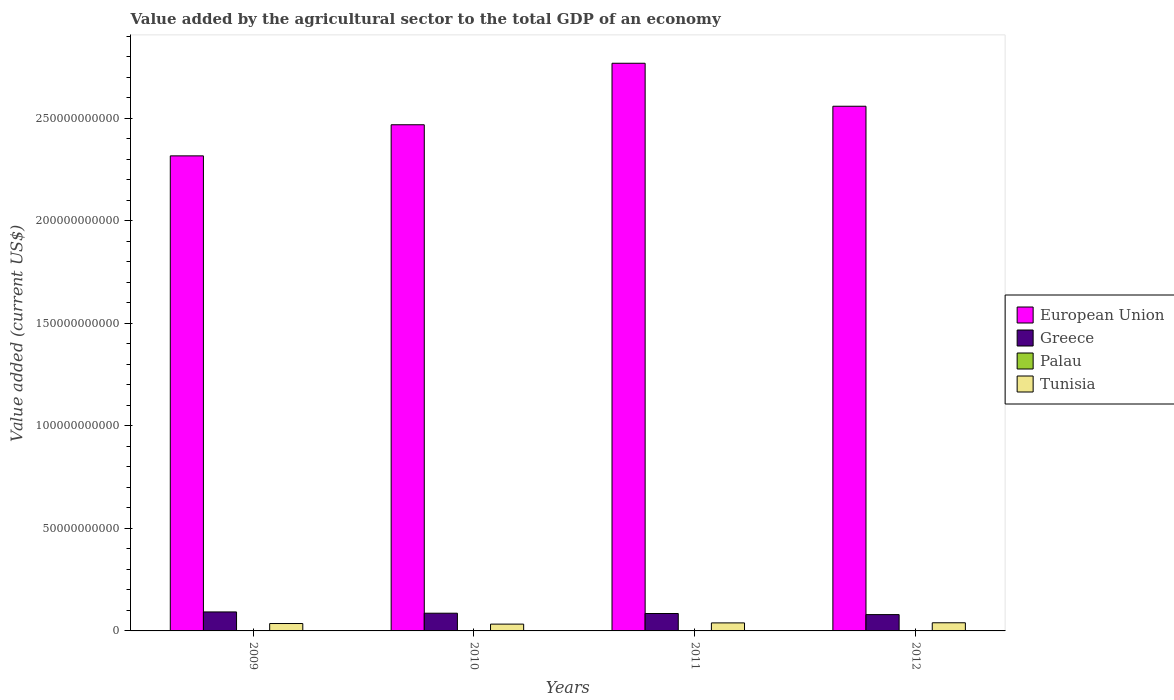Are the number of bars on each tick of the X-axis equal?
Ensure brevity in your answer.  Yes. How many bars are there on the 4th tick from the left?
Give a very brief answer. 4. How many bars are there on the 2nd tick from the right?
Your response must be concise. 4. What is the label of the 4th group of bars from the left?
Your answer should be very brief. 2012. In how many cases, is the number of bars for a given year not equal to the number of legend labels?
Offer a terse response. 0. What is the value added by the agricultural sector to the total GDP in Palau in 2009?
Give a very brief answer. 7.90e+06. Across all years, what is the maximum value added by the agricultural sector to the total GDP in European Union?
Give a very brief answer. 2.77e+11. Across all years, what is the minimum value added by the agricultural sector to the total GDP in Greece?
Provide a succinct answer. 7.95e+09. What is the total value added by the agricultural sector to the total GDP in Palau in the graph?
Provide a succinct answer. 3.33e+07. What is the difference between the value added by the agricultural sector to the total GDP in Greece in 2010 and that in 2011?
Offer a terse response. 1.43e+08. What is the difference between the value added by the agricultural sector to the total GDP in Tunisia in 2009 and the value added by the agricultural sector to the total GDP in Palau in 2012?
Provide a succinct answer. 3.60e+09. What is the average value added by the agricultural sector to the total GDP in European Union per year?
Your answer should be very brief. 2.53e+11. In the year 2010, what is the difference between the value added by the agricultural sector to the total GDP in European Union and value added by the agricultural sector to the total GDP in Greece?
Keep it short and to the point. 2.38e+11. In how many years, is the value added by the agricultural sector to the total GDP in Tunisia greater than 220000000000 US$?
Offer a very short reply. 0. What is the ratio of the value added by the agricultural sector to the total GDP in European Union in 2010 to that in 2012?
Offer a terse response. 0.96. Is the value added by the agricultural sector to the total GDP in Tunisia in 2010 less than that in 2011?
Keep it short and to the point. Yes. Is the difference between the value added by the agricultural sector to the total GDP in European Union in 2009 and 2011 greater than the difference between the value added by the agricultural sector to the total GDP in Greece in 2009 and 2011?
Your answer should be very brief. No. What is the difference between the highest and the second highest value added by the agricultural sector to the total GDP in Greece?
Your answer should be compact. 6.22e+08. What is the difference between the highest and the lowest value added by the agricultural sector to the total GDP in Palau?
Provide a short and direct response. 1.59e+06. Is the sum of the value added by the agricultural sector to the total GDP in European Union in 2009 and 2012 greater than the maximum value added by the agricultural sector to the total GDP in Tunisia across all years?
Provide a succinct answer. Yes. Is it the case that in every year, the sum of the value added by the agricultural sector to the total GDP in Tunisia and value added by the agricultural sector to the total GDP in Greece is greater than the sum of value added by the agricultural sector to the total GDP in Palau and value added by the agricultural sector to the total GDP in European Union?
Your answer should be very brief. No. What does the 4th bar from the left in 2009 represents?
Your answer should be very brief. Tunisia. Is it the case that in every year, the sum of the value added by the agricultural sector to the total GDP in European Union and value added by the agricultural sector to the total GDP in Palau is greater than the value added by the agricultural sector to the total GDP in Greece?
Offer a terse response. Yes. How many years are there in the graph?
Offer a terse response. 4. Does the graph contain any zero values?
Offer a terse response. No. Where does the legend appear in the graph?
Give a very brief answer. Center right. How many legend labels are there?
Your answer should be very brief. 4. How are the legend labels stacked?
Your answer should be compact. Vertical. What is the title of the graph?
Ensure brevity in your answer.  Value added by the agricultural sector to the total GDP of an economy. Does "Angola" appear as one of the legend labels in the graph?
Your answer should be very brief. No. What is the label or title of the Y-axis?
Your answer should be very brief. Value added (current US$). What is the Value added (current US$) of European Union in 2009?
Keep it short and to the point. 2.32e+11. What is the Value added (current US$) of Greece in 2009?
Ensure brevity in your answer.  9.26e+09. What is the Value added (current US$) in Palau in 2009?
Your answer should be very brief. 7.90e+06. What is the Value added (current US$) of Tunisia in 2009?
Keep it short and to the point. 3.61e+09. What is the Value added (current US$) in European Union in 2010?
Keep it short and to the point. 2.47e+11. What is the Value added (current US$) in Greece in 2010?
Your answer should be compact. 8.63e+09. What is the Value added (current US$) of Palau in 2010?
Provide a succinct answer. 7.58e+06. What is the Value added (current US$) of Tunisia in 2010?
Provide a short and direct response. 3.32e+09. What is the Value added (current US$) in European Union in 2011?
Offer a terse response. 2.77e+11. What is the Value added (current US$) of Greece in 2011?
Provide a succinct answer. 8.49e+09. What is the Value added (current US$) of Palau in 2011?
Keep it short and to the point. 8.69e+06. What is the Value added (current US$) in Tunisia in 2011?
Offer a terse response. 3.91e+09. What is the Value added (current US$) in European Union in 2012?
Keep it short and to the point. 2.56e+11. What is the Value added (current US$) in Greece in 2012?
Provide a short and direct response. 7.95e+09. What is the Value added (current US$) in Palau in 2012?
Ensure brevity in your answer.  9.17e+06. What is the Value added (current US$) of Tunisia in 2012?
Give a very brief answer. 3.98e+09. Across all years, what is the maximum Value added (current US$) in European Union?
Your response must be concise. 2.77e+11. Across all years, what is the maximum Value added (current US$) of Greece?
Offer a terse response. 9.26e+09. Across all years, what is the maximum Value added (current US$) in Palau?
Provide a short and direct response. 9.17e+06. Across all years, what is the maximum Value added (current US$) of Tunisia?
Offer a terse response. 3.98e+09. Across all years, what is the minimum Value added (current US$) of European Union?
Keep it short and to the point. 2.32e+11. Across all years, what is the minimum Value added (current US$) of Greece?
Make the answer very short. 7.95e+09. Across all years, what is the minimum Value added (current US$) of Palau?
Your answer should be compact. 7.58e+06. Across all years, what is the minimum Value added (current US$) in Tunisia?
Your answer should be compact. 3.32e+09. What is the total Value added (current US$) of European Union in the graph?
Your answer should be compact. 1.01e+12. What is the total Value added (current US$) in Greece in the graph?
Offer a very short reply. 3.43e+1. What is the total Value added (current US$) in Palau in the graph?
Keep it short and to the point. 3.33e+07. What is the total Value added (current US$) of Tunisia in the graph?
Keep it short and to the point. 1.48e+1. What is the difference between the Value added (current US$) in European Union in 2009 and that in 2010?
Offer a very short reply. -1.52e+1. What is the difference between the Value added (current US$) of Greece in 2009 and that in 2010?
Your answer should be compact. 6.22e+08. What is the difference between the Value added (current US$) in Palau in 2009 and that in 2010?
Provide a succinct answer. 3.15e+05. What is the difference between the Value added (current US$) of Tunisia in 2009 and that in 2010?
Ensure brevity in your answer.  2.87e+08. What is the difference between the Value added (current US$) in European Union in 2009 and that in 2011?
Offer a terse response. -4.52e+1. What is the difference between the Value added (current US$) of Greece in 2009 and that in 2011?
Provide a succinct answer. 7.65e+08. What is the difference between the Value added (current US$) in Palau in 2009 and that in 2011?
Your response must be concise. -7.94e+05. What is the difference between the Value added (current US$) in Tunisia in 2009 and that in 2011?
Offer a terse response. -3.08e+08. What is the difference between the Value added (current US$) of European Union in 2009 and that in 2012?
Give a very brief answer. -2.42e+1. What is the difference between the Value added (current US$) in Greece in 2009 and that in 2012?
Offer a very short reply. 1.30e+09. What is the difference between the Value added (current US$) in Palau in 2009 and that in 2012?
Your response must be concise. -1.28e+06. What is the difference between the Value added (current US$) in Tunisia in 2009 and that in 2012?
Provide a succinct answer. -3.70e+08. What is the difference between the Value added (current US$) of European Union in 2010 and that in 2011?
Provide a succinct answer. -3.00e+1. What is the difference between the Value added (current US$) of Greece in 2010 and that in 2011?
Your response must be concise. 1.43e+08. What is the difference between the Value added (current US$) in Palau in 2010 and that in 2011?
Give a very brief answer. -1.11e+06. What is the difference between the Value added (current US$) in Tunisia in 2010 and that in 2011?
Your answer should be very brief. -5.94e+08. What is the difference between the Value added (current US$) of European Union in 2010 and that in 2012?
Your response must be concise. -9.03e+09. What is the difference between the Value added (current US$) in Greece in 2010 and that in 2012?
Provide a short and direct response. 6.80e+08. What is the difference between the Value added (current US$) of Palau in 2010 and that in 2012?
Give a very brief answer. -1.59e+06. What is the difference between the Value added (current US$) of Tunisia in 2010 and that in 2012?
Provide a succinct answer. -6.56e+08. What is the difference between the Value added (current US$) of European Union in 2011 and that in 2012?
Ensure brevity in your answer.  2.10e+1. What is the difference between the Value added (current US$) in Greece in 2011 and that in 2012?
Offer a very short reply. 5.37e+08. What is the difference between the Value added (current US$) of Palau in 2011 and that in 2012?
Your answer should be very brief. -4.81e+05. What is the difference between the Value added (current US$) in Tunisia in 2011 and that in 2012?
Your answer should be very brief. -6.18e+07. What is the difference between the Value added (current US$) in European Union in 2009 and the Value added (current US$) in Greece in 2010?
Provide a succinct answer. 2.23e+11. What is the difference between the Value added (current US$) of European Union in 2009 and the Value added (current US$) of Palau in 2010?
Your response must be concise. 2.32e+11. What is the difference between the Value added (current US$) of European Union in 2009 and the Value added (current US$) of Tunisia in 2010?
Provide a succinct answer. 2.28e+11. What is the difference between the Value added (current US$) of Greece in 2009 and the Value added (current US$) of Palau in 2010?
Your answer should be compact. 9.25e+09. What is the difference between the Value added (current US$) in Greece in 2009 and the Value added (current US$) in Tunisia in 2010?
Give a very brief answer. 5.94e+09. What is the difference between the Value added (current US$) in Palau in 2009 and the Value added (current US$) in Tunisia in 2010?
Your response must be concise. -3.31e+09. What is the difference between the Value added (current US$) of European Union in 2009 and the Value added (current US$) of Greece in 2011?
Keep it short and to the point. 2.23e+11. What is the difference between the Value added (current US$) of European Union in 2009 and the Value added (current US$) of Palau in 2011?
Give a very brief answer. 2.32e+11. What is the difference between the Value added (current US$) in European Union in 2009 and the Value added (current US$) in Tunisia in 2011?
Offer a terse response. 2.28e+11. What is the difference between the Value added (current US$) in Greece in 2009 and the Value added (current US$) in Palau in 2011?
Your answer should be compact. 9.25e+09. What is the difference between the Value added (current US$) of Greece in 2009 and the Value added (current US$) of Tunisia in 2011?
Offer a terse response. 5.34e+09. What is the difference between the Value added (current US$) in Palau in 2009 and the Value added (current US$) in Tunisia in 2011?
Offer a very short reply. -3.91e+09. What is the difference between the Value added (current US$) of European Union in 2009 and the Value added (current US$) of Greece in 2012?
Provide a succinct answer. 2.24e+11. What is the difference between the Value added (current US$) of European Union in 2009 and the Value added (current US$) of Palau in 2012?
Offer a terse response. 2.32e+11. What is the difference between the Value added (current US$) in European Union in 2009 and the Value added (current US$) in Tunisia in 2012?
Provide a succinct answer. 2.28e+11. What is the difference between the Value added (current US$) in Greece in 2009 and the Value added (current US$) in Palau in 2012?
Ensure brevity in your answer.  9.25e+09. What is the difference between the Value added (current US$) of Greece in 2009 and the Value added (current US$) of Tunisia in 2012?
Offer a very short reply. 5.28e+09. What is the difference between the Value added (current US$) in Palau in 2009 and the Value added (current US$) in Tunisia in 2012?
Keep it short and to the point. -3.97e+09. What is the difference between the Value added (current US$) in European Union in 2010 and the Value added (current US$) in Greece in 2011?
Ensure brevity in your answer.  2.38e+11. What is the difference between the Value added (current US$) in European Union in 2010 and the Value added (current US$) in Palau in 2011?
Your answer should be very brief. 2.47e+11. What is the difference between the Value added (current US$) of European Union in 2010 and the Value added (current US$) of Tunisia in 2011?
Provide a succinct answer. 2.43e+11. What is the difference between the Value added (current US$) of Greece in 2010 and the Value added (current US$) of Palau in 2011?
Make the answer very short. 8.63e+09. What is the difference between the Value added (current US$) in Greece in 2010 and the Value added (current US$) in Tunisia in 2011?
Your answer should be very brief. 4.72e+09. What is the difference between the Value added (current US$) of Palau in 2010 and the Value added (current US$) of Tunisia in 2011?
Provide a succinct answer. -3.91e+09. What is the difference between the Value added (current US$) of European Union in 2010 and the Value added (current US$) of Greece in 2012?
Your answer should be very brief. 2.39e+11. What is the difference between the Value added (current US$) in European Union in 2010 and the Value added (current US$) in Palau in 2012?
Ensure brevity in your answer.  2.47e+11. What is the difference between the Value added (current US$) in European Union in 2010 and the Value added (current US$) in Tunisia in 2012?
Provide a succinct answer. 2.43e+11. What is the difference between the Value added (current US$) in Greece in 2010 and the Value added (current US$) in Palau in 2012?
Your answer should be very brief. 8.63e+09. What is the difference between the Value added (current US$) of Greece in 2010 and the Value added (current US$) of Tunisia in 2012?
Keep it short and to the point. 4.66e+09. What is the difference between the Value added (current US$) of Palau in 2010 and the Value added (current US$) of Tunisia in 2012?
Offer a terse response. -3.97e+09. What is the difference between the Value added (current US$) of European Union in 2011 and the Value added (current US$) of Greece in 2012?
Your answer should be compact. 2.69e+11. What is the difference between the Value added (current US$) of European Union in 2011 and the Value added (current US$) of Palau in 2012?
Ensure brevity in your answer.  2.77e+11. What is the difference between the Value added (current US$) in European Union in 2011 and the Value added (current US$) in Tunisia in 2012?
Your answer should be compact. 2.73e+11. What is the difference between the Value added (current US$) in Greece in 2011 and the Value added (current US$) in Palau in 2012?
Your response must be concise. 8.48e+09. What is the difference between the Value added (current US$) of Greece in 2011 and the Value added (current US$) of Tunisia in 2012?
Keep it short and to the point. 4.52e+09. What is the difference between the Value added (current US$) of Palau in 2011 and the Value added (current US$) of Tunisia in 2012?
Make the answer very short. -3.97e+09. What is the average Value added (current US$) in European Union per year?
Your answer should be very brief. 2.53e+11. What is the average Value added (current US$) of Greece per year?
Ensure brevity in your answer.  8.58e+09. What is the average Value added (current US$) of Palau per year?
Ensure brevity in your answer.  8.33e+06. What is the average Value added (current US$) of Tunisia per year?
Offer a very short reply. 3.70e+09. In the year 2009, what is the difference between the Value added (current US$) in European Union and Value added (current US$) in Greece?
Your answer should be compact. 2.22e+11. In the year 2009, what is the difference between the Value added (current US$) of European Union and Value added (current US$) of Palau?
Offer a very short reply. 2.32e+11. In the year 2009, what is the difference between the Value added (current US$) of European Union and Value added (current US$) of Tunisia?
Your answer should be very brief. 2.28e+11. In the year 2009, what is the difference between the Value added (current US$) of Greece and Value added (current US$) of Palau?
Your response must be concise. 9.25e+09. In the year 2009, what is the difference between the Value added (current US$) of Greece and Value added (current US$) of Tunisia?
Keep it short and to the point. 5.65e+09. In the year 2009, what is the difference between the Value added (current US$) in Palau and Value added (current US$) in Tunisia?
Your answer should be very brief. -3.60e+09. In the year 2010, what is the difference between the Value added (current US$) in European Union and Value added (current US$) in Greece?
Provide a succinct answer. 2.38e+11. In the year 2010, what is the difference between the Value added (current US$) in European Union and Value added (current US$) in Palau?
Your answer should be compact. 2.47e+11. In the year 2010, what is the difference between the Value added (current US$) of European Union and Value added (current US$) of Tunisia?
Your response must be concise. 2.43e+11. In the year 2010, what is the difference between the Value added (current US$) of Greece and Value added (current US$) of Palau?
Ensure brevity in your answer.  8.63e+09. In the year 2010, what is the difference between the Value added (current US$) in Greece and Value added (current US$) in Tunisia?
Give a very brief answer. 5.32e+09. In the year 2010, what is the difference between the Value added (current US$) of Palau and Value added (current US$) of Tunisia?
Give a very brief answer. -3.31e+09. In the year 2011, what is the difference between the Value added (current US$) of European Union and Value added (current US$) of Greece?
Offer a very short reply. 2.68e+11. In the year 2011, what is the difference between the Value added (current US$) in European Union and Value added (current US$) in Palau?
Keep it short and to the point. 2.77e+11. In the year 2011, what is the difference between the Value added (current US$) in European Union and Value added (current US$) in Tunisia?
Your answer should be very brief. 2.73e+11. In the year 2011, what is the difference between the Value added (current US$) of Greece and Value added (current US$) of Palau?
Your response must be concise. 8.48e+09. In the year 2011, what is the difference between the Value added (current US$) of Greece and Value added (current US$) of Tunisia?
Your response must be concise. 4.58e+09. In the year 2011, what is the difference between the Value added (current US$) of Palau and Value added (current US$) of Tunisia?
Provide a short and direct response. -3.90e+09. In the year 2012, what is the difference between the Value added (current US$) of European Union and Value added (current US$) of Greece?
Provide a succinct answer. 2.48e+11. In the year 2012, what is the difference between the Value added (current US$) in European Union and Value added (current US$) in Palau?
Keep it short and to the point. 2.56e+11. In the year 2012, what is the difference between the Value added (current US$) of European Union and Value added (current US$) of Tunisia?
Your response must be concise. 2.52e+11. In the year 2012, what is the difference between the Value added (current US$) of Greece and Value added (current US$) of Palau?
Keep it short and to the point. 7.94e+09. In the year 2012, what is the difference between the Value added (current US$) in Greece and Value added (current US$) in Tunisia?
Offer a very short reply. 3.98e+09. In the year 2012, what is the difference between the Value added (current US$) of Palau and Value added (current US$) of Tunisia?
Provide a succinct answer. -3.97e+09. What is the ratio of the Value added (current US$) in European Union in 2009 to that in 2010?
Provide a succinct answer. 0.94. What is the ratio of the Value added (current US$) in Greece in 2009 to that in 2010?
Provide a short and direct response. 1.07. What is the ratio of the Value added (current US$) in Palau in 2009 to that in 2010?
Offer a very short reply. 1.04. What is the ratio of the Value added (current US$) of Tunisia in 2009 to that in 2010?
Your response must be concise. 1.09. What is the ratio of the Value added (current US$) of European Union in 2009 to that in 2011?
Your answer should be compact. 0.84. What is the ratio of the Value added (current US$) of Greece in 2009 to that in 2011?
Offer a terse response. 1.09. What is the ratio of the Value added (current US$) in Palau in 2009 to that in 2011?
Your answer should be compact. 0.91. What is the ratio of the Value added (current US$) of Tunisia in 2009 to that in 2011?
Your answer should be very brief. 0.92. What is the ratio of the Value added (current US$) in European Union in 2009 to that in 2012?
Ensure brevity in your answer.  0.91. What is the ratio of the Value added (current US$) in Greece in 2009 to that in 2012?
Offer a very short reply. 1.16. What is the ratio of the Value added (current US$) of Palau in 2009 to that in 2012?
Offer a terse response. 0.86. What is the ratio of the Value added (current US$) in Tunisia in 2009 to that in 2012?
Give a very brief answer. 0.91. What is the ratio of the Value added (current US$) in European Union in 2010 to that in 2011?
Keep it short and to the point. 0.89. What is the ratio of the Value added (current US$) of Greece in 2010 to that in 2011?
Provide a succinct answer. 1.02. What is the ratio of the Value added (current US$) of Palau in 2010 to that in 2011?
Give a very brief answer. 0.87. What is the ratio of the Value added (current US$) in Tunisia in 2010 to that in 2011?
Provide a short and direct response. 0.85. What is the ratio of the Value added (current US$) of European Union in 2010 to that in 2012?
Your answer should be very brief. 0.96. What is the ratio of the Value added (current US$) of Greece in 2010 to that in 2012?
Provide a short and direct response. 1.09. What is the ratio of the Value added (current US$) in Palau in 2010 to that in 2012?
Provide a succinct answer. 0.83. What is the ratio of the Value added (current US$) in Tunisia in 2010 to that in 2012?
Offer a very short reply. 0.83. What is the ratio of the Value added (current US$) of European Union in 2011 to that in 2012?
Keep it short and to the point. 1.08. What is the ratio of the Value added (current US$) of Greece in 2011 to that in 2012?
Offer a very short reply. 1.07. What is the ratio of the Value added (current US$) of Palau in 2011 to that in 2012?
Your answer should be compact. 0.95. What is the ratio of the Value added (current US$) in Tunisia in 2011 to that in 2012?
Your response must be concise. 0.98. What is the difference between the highest and the second highest Value added (current US$) in European Union?
Make the answer very short. 2.10e+1. What is the difference between the highest and the second highest Value added (current US$) of Greece?
Your answer should be compact. 6.22e+08. What is the difference between the highest and the second highest Value added (current US$) of Palau?
Your response must be concise. 4.81e+05. What is the difference between the highest and the second highest Value added (current US$) in Tunisia?
Ensure brevity in your answer.  6.18e+07. What is the difference between the highest and the lowest Value added (current US$) in European Union?
Ensure brevity in your answer.  4.52e+1. What is the difference between the highest and the lowest Value added (current US$) of Greece?
Keep it short and to the point. 1.30e+09. What is the difference between the highest and the lowest Value added (current US$) of Palau?
Offer a very short reply. 1.59e+06. What is the difference between the highest and the lowest Value added (current US$) in Tunisia?
Give a very brief answer. 6.56e+08. 